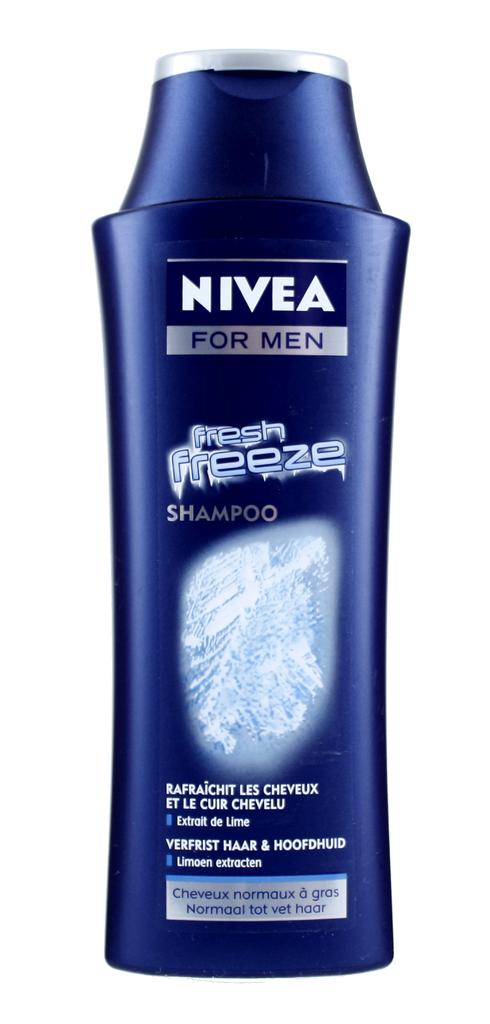Who is the nivea for?
Provide a succinct answer. Men. 